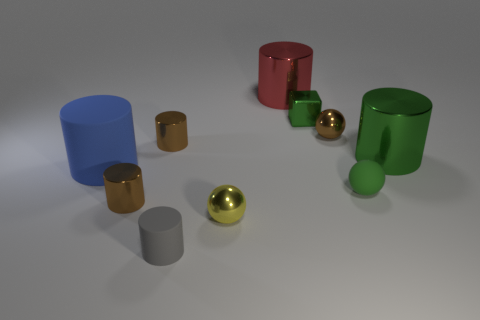What number of other cylinders have the same size as the gray cylinder?
Your answer should be compact. 2. How many tiny yellow matte cylinders are there?
Ensure brevity in your answer.  0. Is the material of the small yellow sphere the same as the brown object on the right side of the yellow sphere?
Keep it short and to the point. Yes. What number of green things are either small metal cylinders or small shiny cubes?
Offer a very short reply. 1. What size is the green thing that is made of the same material as the small block?
Your response must be concise. Large. How many small gray rubber things have the same shape as the red shiny thing?
Make the answer very short. 1. Are there more blue objects behind the cube than small brown balls that are in front of the matte ball?
Keep it short and to the point. No. There is a tiny cube; is it the same color as the matte cylinder in front of the large rubber cylinder?
Keep it short and to the point. No. There is a green sphere that is the same size as the green metal cube; what is its material?
Offer a very short reply. Rubber. How many objects are either brown cubes or brown objects that are right of the tiny gray rubber cylinder?
Ensure brevity in your answer.  1. 